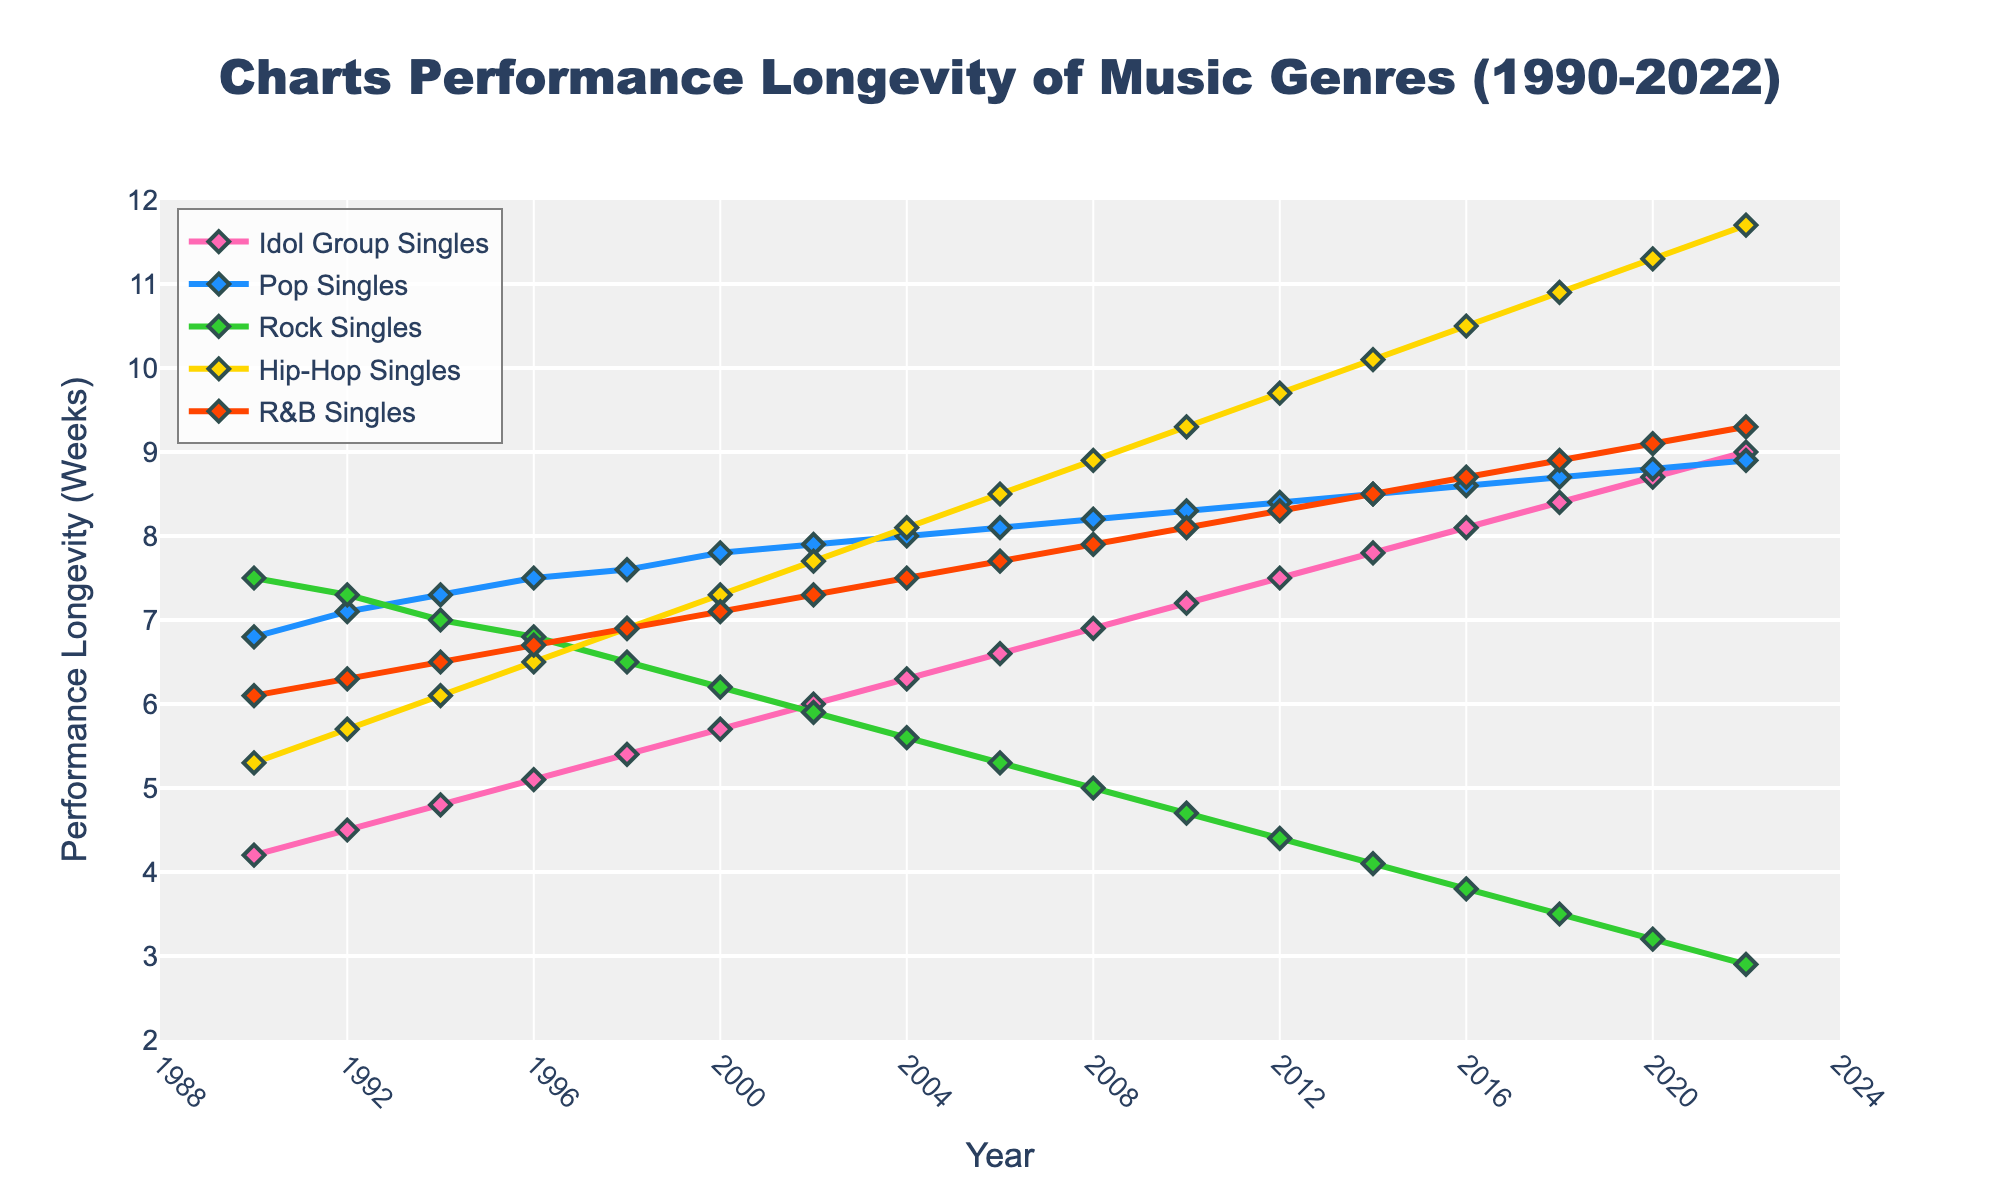Which music genre shows the highest performance longevity consistently throughout the years? By observing the plotted lines, the Hip-Hop Singles consistently have the highest performance longevity values compared to other genres at almost all time points from 1990 to 2022.
Answer: Hip-Hop Singles What was the performance longevity for Pop Singles in 2000? Identify the data point for Pop Singles at the year 2000 in the figure. The y-axis value for Pop Singles in 2000 is 7.8 weeks.
Answer: 7.8 weeks Did Idol Group Singles ever surpass the longevity of Pop Singles in the given timeframe? Compare the lines for Idol Group Singles and Pop Singles across the years. Idol Group Singles remain below Pop Singles throughout the given timeframe; therefore, Idol Group Singles did not surpass Pop Singles.
Answer: No In which year did Idol Group Singles first reach a performance longevity of 8.0 weeks? Track the line for Idol Group Singles and find the year where it first hits or exceeds the 8.0 weeks mark. It reaches 8.0 weeks in 2016.
Answer: 2016 What is the difference in the performance longevity of Rock Singles between 1990 and 2022? Examine the endpoints of the Rock Singles line in the years 1990 and 2022. The longevity in 1990 was 7.5 weeks and in 2022 it was 2.9 weeks. The difference is 7.5 - 2.9 weeks.
Answer: 4.6 weeks During what period did R&B Singles surpass Pop Singles in performance longevity, if at all? By examining the lines, especially focusing on interactions and crossing points, R&B Singles do not surpass Pop Singles at any point from 1990 to 2022.
Answer: Never What is the average performance longevity of Idol Group Singles from 1990 to 2022? Calculate the mean of the Idol Group Singles values: (4.2 + 4.5 + 4.8 + 5.1 + 5.4 + 5.7 + 6.0 + 6.3 + 6.6 + 6.9 + 7.2 + 7.5 + 7.8 + 8.1 + 8.4 + 8.7 + 9.0) / 17 = 6.52
Answer: 6.52 weeks In which years did Rock Singles have the same performance longevity values as Hip-Hop Singles? Track the lines for Hip-Hop Singles and Rock Singles and find where they intersect or have the same y-axis value. Rock Singles and Hip-Hop Singles do not share the same longevity in any given year in this dataset.
Answer: None 